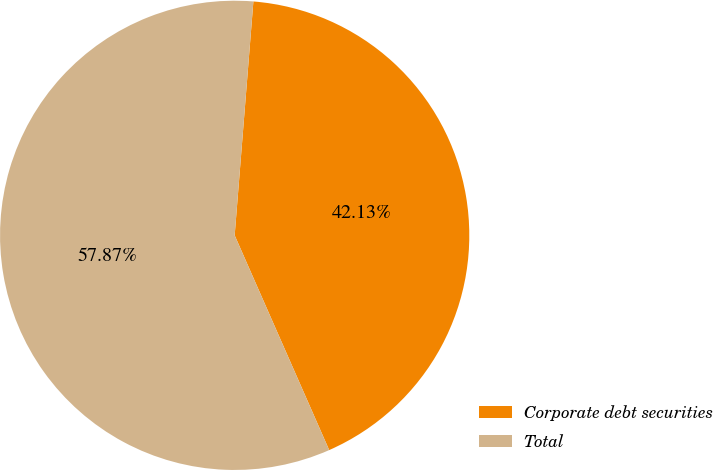<chart> <loc_0><loc_0><loc_500><loc_500><pie_chart><fcel>Corporate debt securities<fcel>Total<nl><fcel>42.13%<fcel>57.87%<nl></chart> 